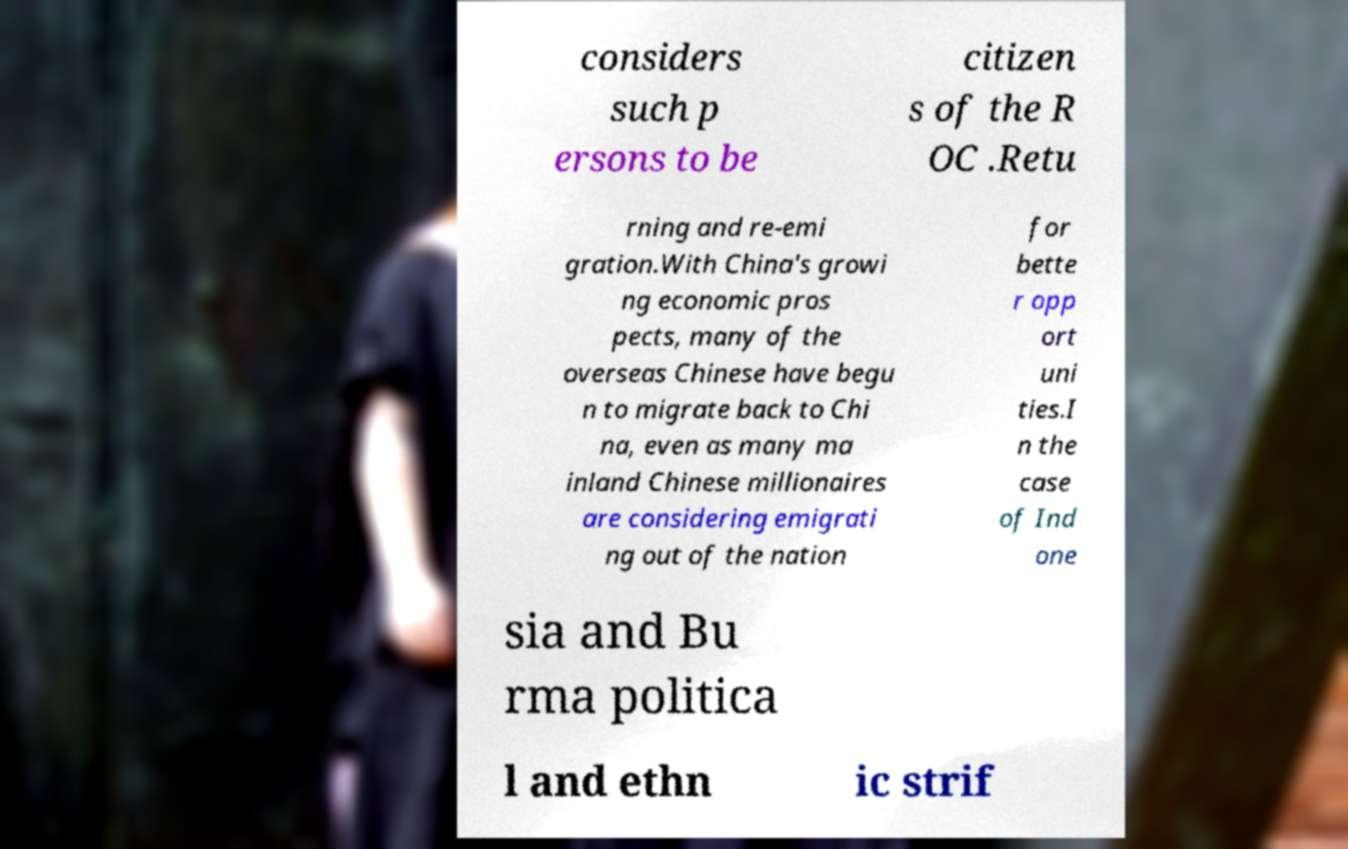Could you extract and type out the text from this image? considers such p ersons to be citizen s of the R OC .Retu rning and re-emi gration.With China's growi ng economic pros pects, many of the overseas Chinese have begu n to migrate back to Chi na, even as many ma inland Chinese millionaires are considering emigrati ng out of the nation for bette r opp ort uni ties.I n the case of Ind one sia and Bu rma politica l and ethn ic strif 